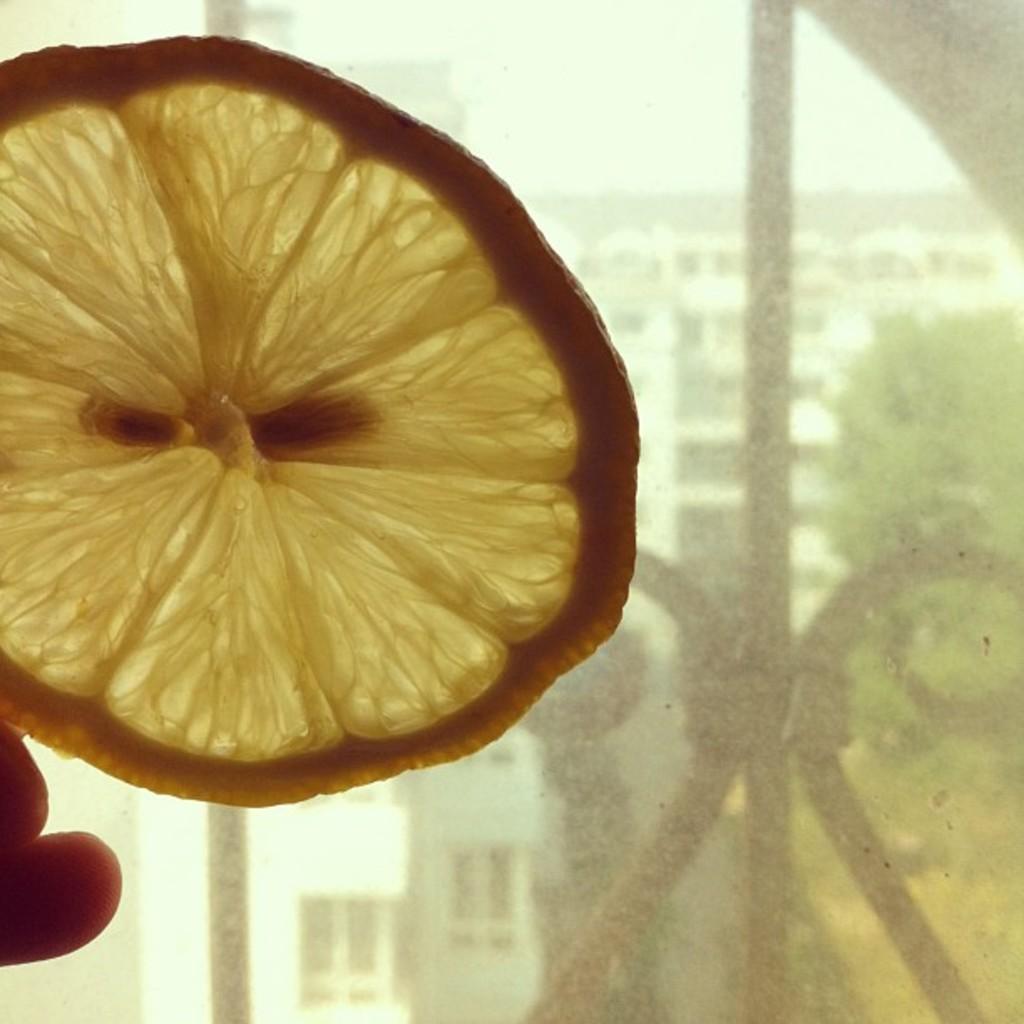Please provide a concise description of this image. In this image, we can see the slice of a lemon. We can see the fingers of a person. We can see some metal objects, buildings and trees. We can also see the sky. 